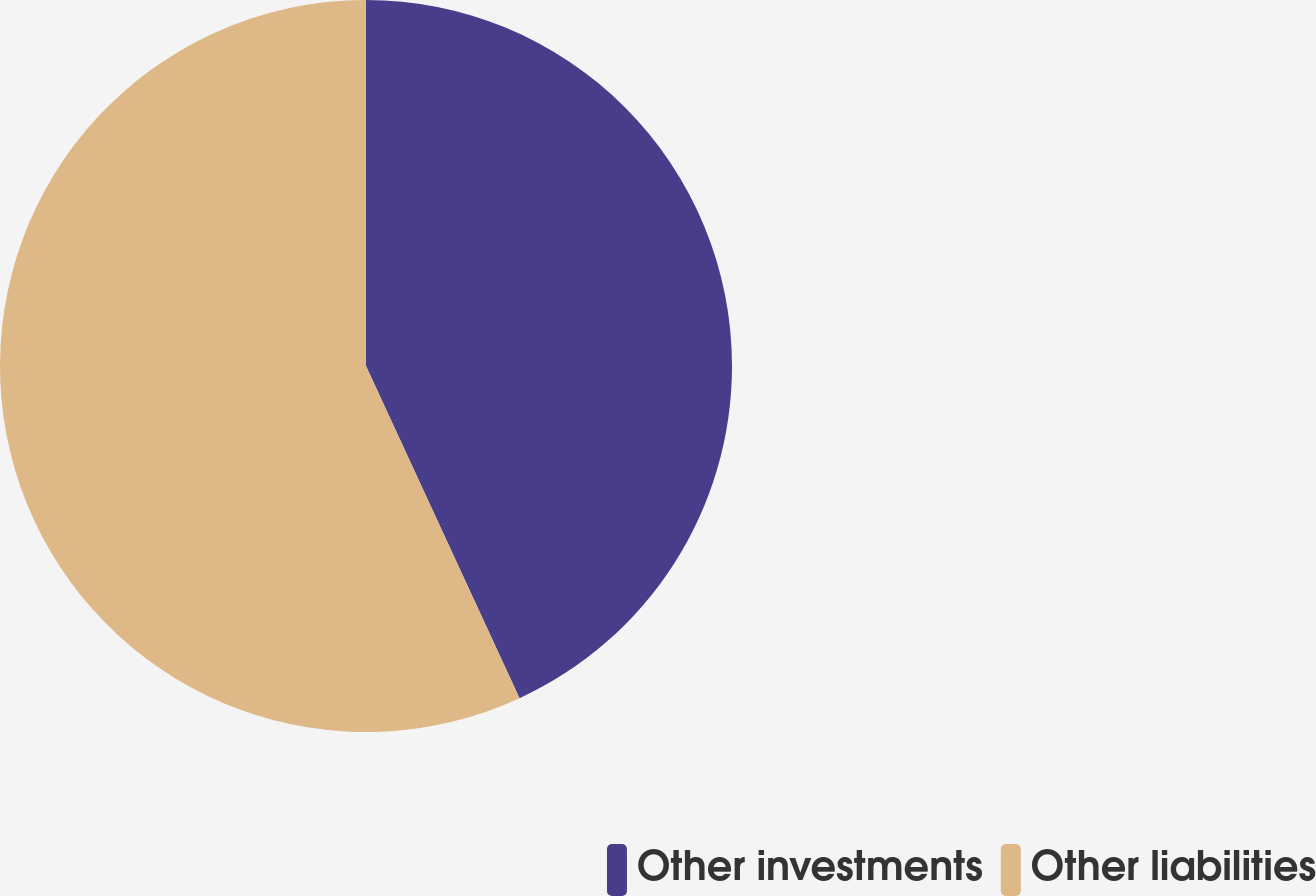Convert chart. <chart><loc_0><loc_0><loc_500><loc_500><pie_chart><fcel>Other investments<fcel>Other liabilities<nl><fcel>43.11%<fcel>56.89%<nl></chart> 